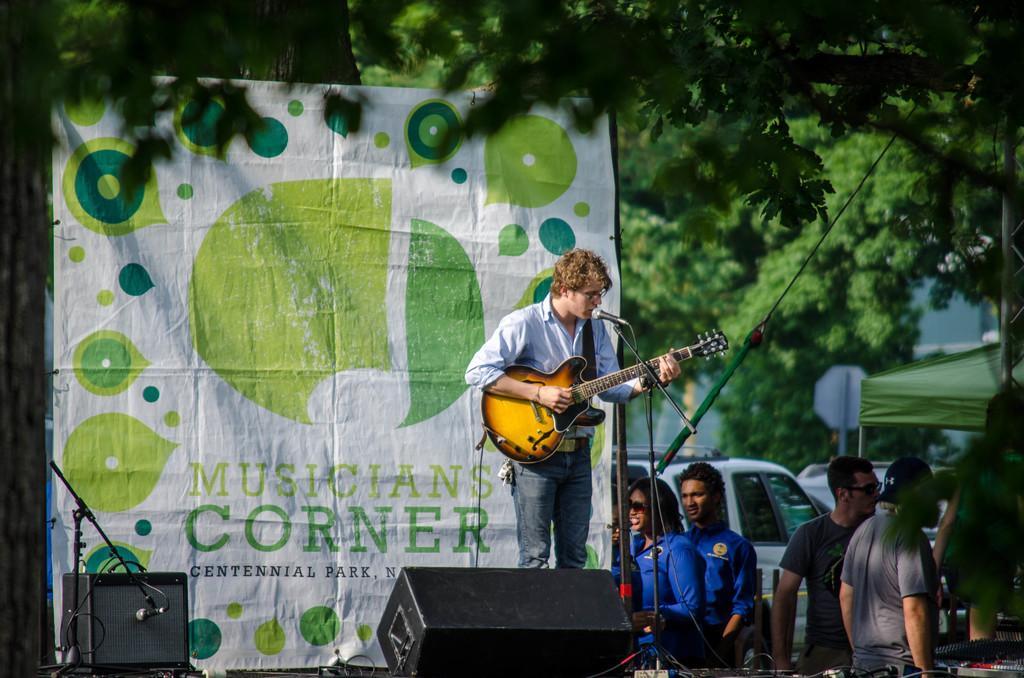In one or two sentences, can you explain what this image depicts? In this image I see man who is standing and he is holding a guitar and he is in front of a mic. I can also see few people over here and In the background I see the cars and the trees and there is a banner over here. 